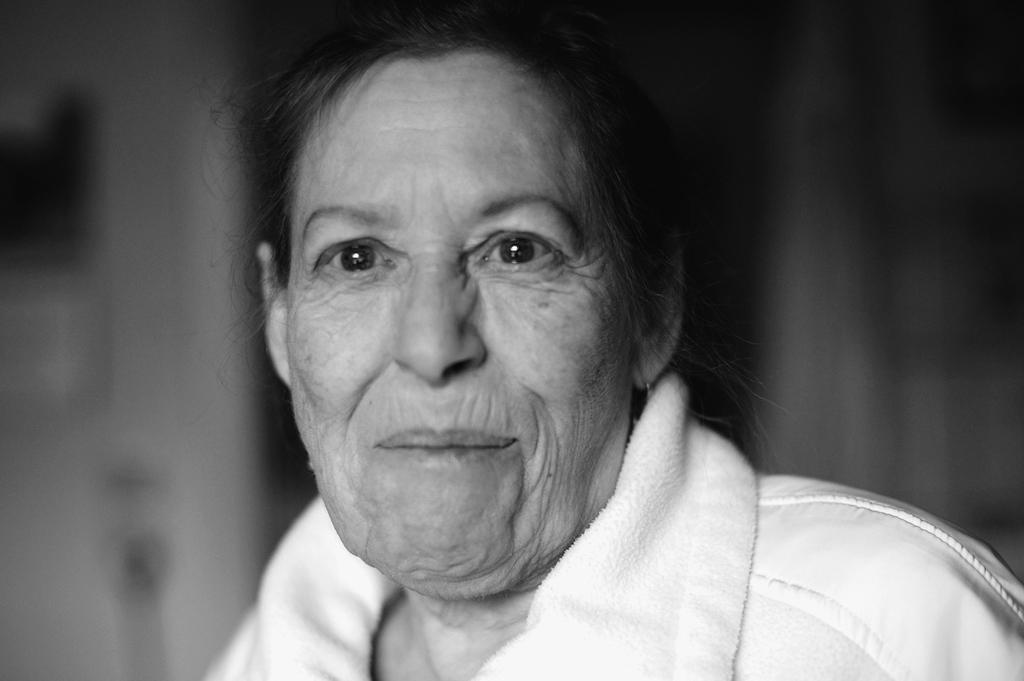In one or two sentences, can you explain what this image depicts? In this image we can see an old lady where has she wore a white color dress. 